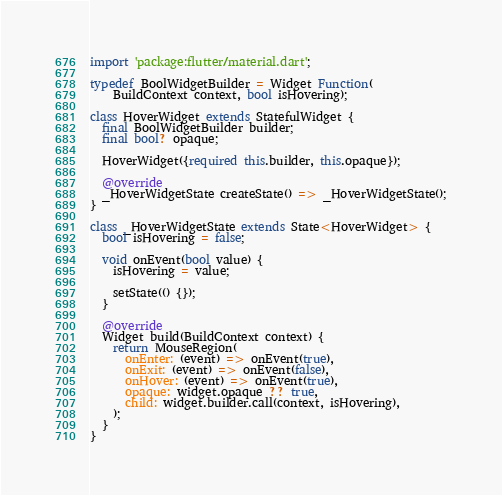<code> <loc_0><loc_0><loc_500><loc_500><_Dart_>import 'package:flutter/material.dart';

typedef BoolWidgetBuilder = Widget Function(
    BuildContext context, bool isHovering);

class HoverWidget extends StatefulWidget {
  final BoolWidgetBuilder builder;
  final bool? opaque;

  HoverWidget({required this.builder, this.opaque});

  @override
  _HoverWidgetState createState() => _HoverWidgetState();
}

class _HoverWidgetState extends State<HoverWidget> {
  bool isHovering = false;

  void onEvent(bool value) {
    isHovering = value;

    setState(() {});
  }

  @override
  Widget build(BuildContext context) {
    return MouseRegion(
      onEnter: (event) => onEvent(true),
      onExit: (event) => onEvent(false),
      onHover: (event) => onEvent(true),
      opaque: widget.opaque ?? true,
      child: widget.builder.call(context, isHovering),
    );
  }
}
</code> 